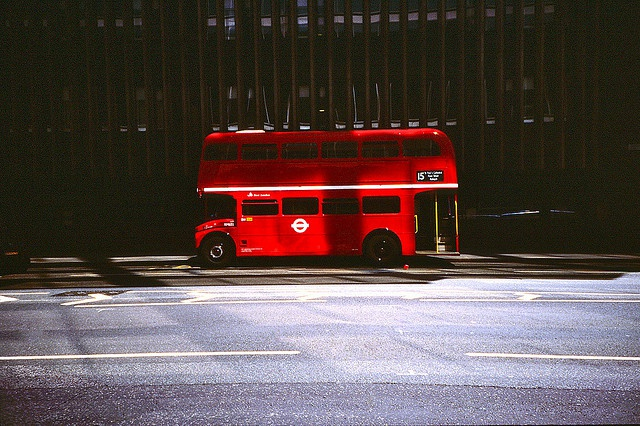Describe the objects in this image and their specific colors. I can see bus in black, maroon, and red tones in this image. 